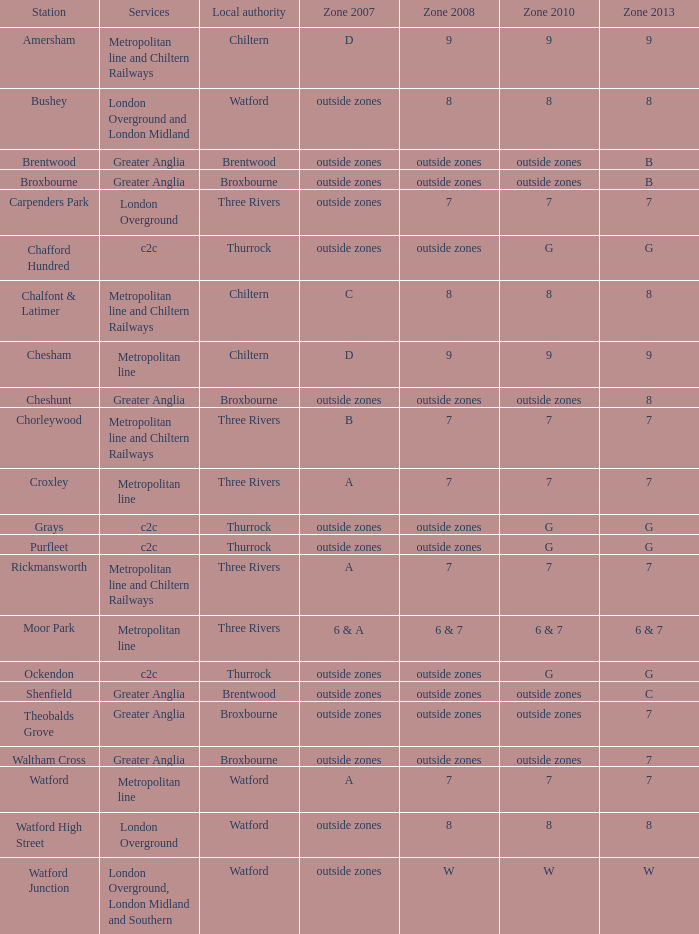Which Station has a Zone 2008 of 8, and a Zone 2007 of outside zones, and Services of london overground? Watford High Street. Can you parse all the data within this table? {'header': ['Station', 'Services', 'Local authority', 'Zone 2007', 'Zone 2008', 'Zone 2010', 'Zone 2013'], 'rows': [['Amersham', 'Metropolitan line and Chiltern Railways', 'Chiltern', 'D', '9', '9', '9'], ['Bushey', 'London Overground and London Midland', 'Watford', 'outside zones', '8', '8', '8'], ['Brentwood', 'Greater Anglia', 'Brentwood', 'outside zones', 'outside zones', 'outside zones', 'B'], ['Broxbourne', 'Greater Anglia', 'Broxbourne', 'outside zones', 'outside zones', 'outside zones', 'B'], ['Carpenders Park', 'London Overground', 'Three Rivers', 'outside zones', '7', '7', '7'], ['Chafford Hundred', 'c2c', 'Thurrock', 'outside zones', 'outside zones', 'G', 'G'], ['Chalfont & Latimer', 'Metropolitan line and Chiltern Railways', 'Chiltern', 'C', '8', '8', '8'], ['Chesham', 'Metropolitan line', 'Chiltern', 'D', '9', '9', '9'], ['Cheshunt', 'Greater Anglia', 'Broxbourne', 'outside zones', 'outside zones', 'outside zones', '8'], ['Chorleywood', 'Metropolitan line and Chiltern Railways', 'Three Rivers', 'B', '7', '7', '7'], ['Croxley', 'Metropolitan line', 'Three Rivers', 'A', '7', '7', '7'], ['Grays', 'c2c', 'Thurrock', 'outside zones', 'outside zones', 'G', 'G'], ['Purfleet', 'c2c', 'Thurrock', 'outside zones', 'outside zones', 'G', 'G'], ['Rickmansworth', 'Metropolitan line and Chiltern Railways', 'Three Rivers', 'A', '7', '7', '7'], ['Moor Park', 'Metropolitan line', 'Three Rivers', '6 & A', '6 & 7', '6 & 7', '6 & 7'], ['Ockendon', 'c2c', 'Thurrock', 'outside zones', 'outside zones', 'G', 'G'], ['Shenfield', 'Greater Anglia', 'Brentwood', 'outside zones', 'outside zones', 'outside zones', 'C'], ['Theobalds Grove', 'Greater Anglia', 'Broxbourne', 'outside zones', 'outside zones', 'outside zones', '7'], ['Waltham Cross', 'Greater Anglia', 'Broxbourne', 'outside zones', 'outside zones', 'outside zones', '7'], ['Watford', 'Metropolitan line', 'Watford', 'A', '7', '7', '7'], ['Watford High Street', 'London Overground', 'Watford', 'outside zones', '8', '8', '8'], ['Watford Junction', 'London Overground, London Midland and Southern', 'Watford', 'outside zones', 'W', 'W', 'W']]} 